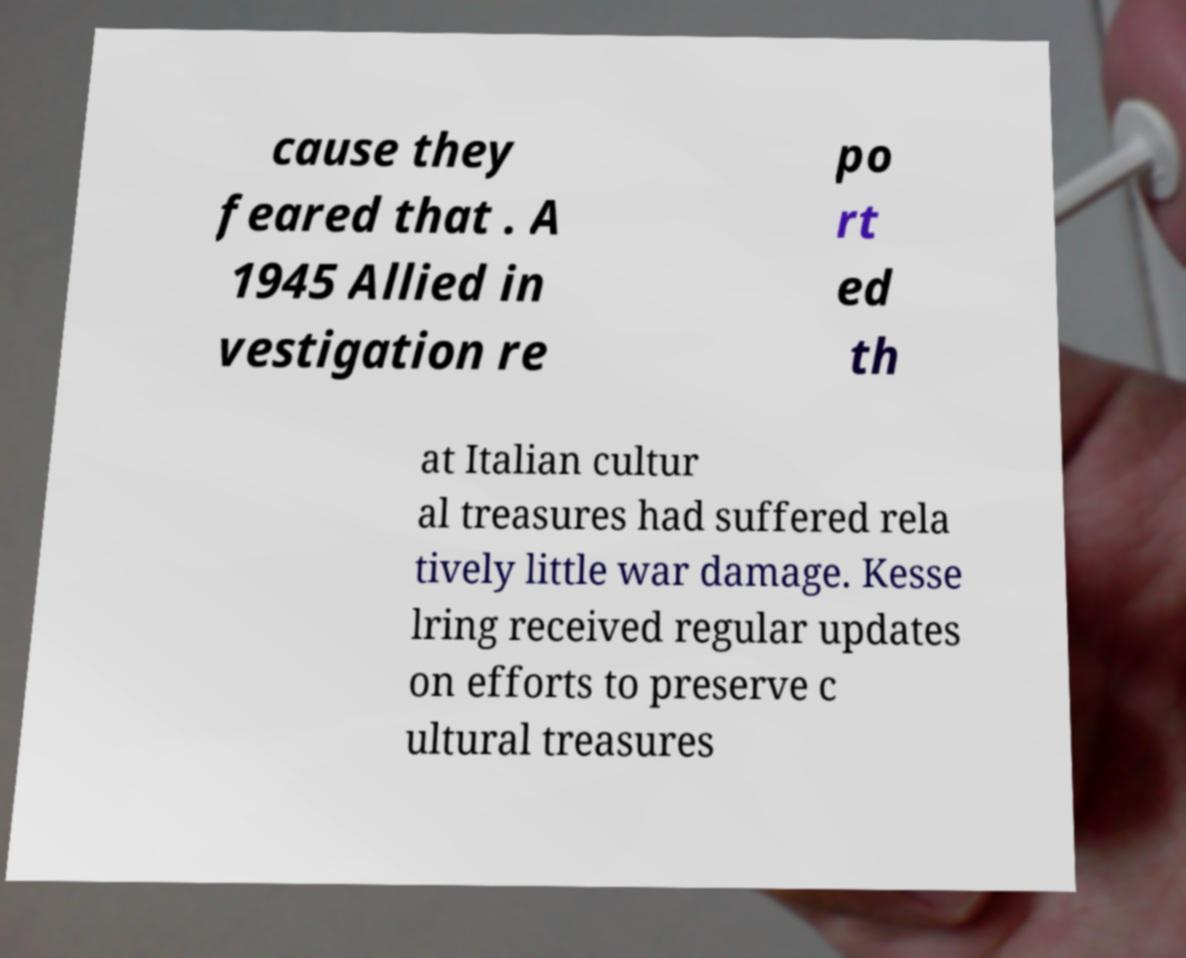Could you assist in decoding the text presented in this image and type it out clearly? cause they feared that . A 1945 Allied in vestigation re po rt ed th at Italian cultur al treasures had suffered rela tively little war damage. Kesse lring received regular updates on efforts to preserve c ultural treasures 